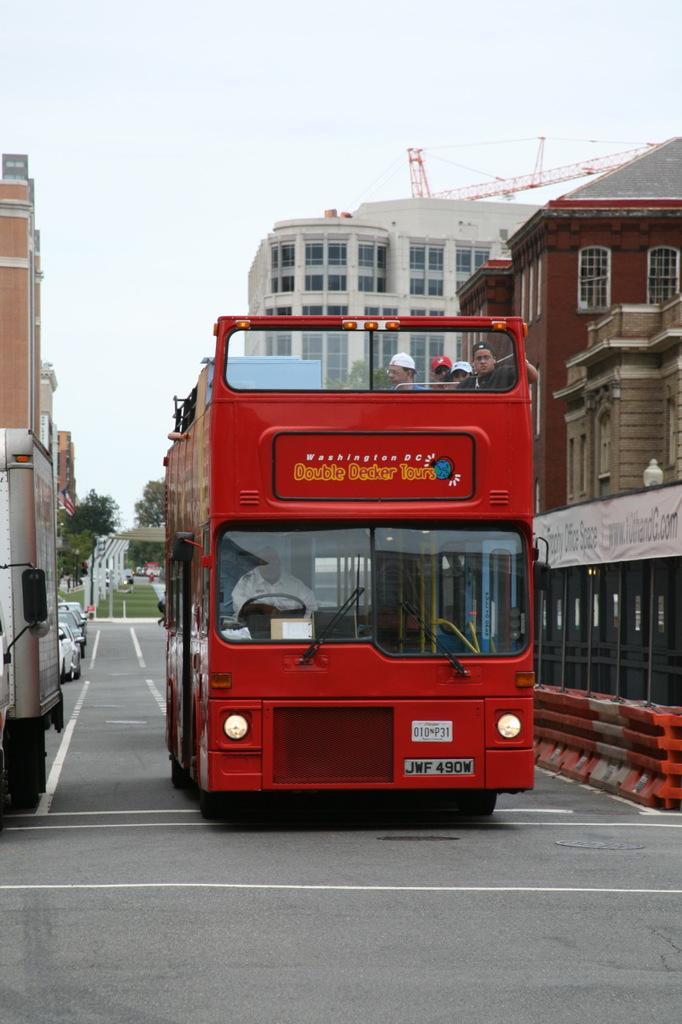Please provide a concise description of this image. In this picture we can see few vehicles on the road, and few people are seated in the bus, in the background we can see few trees, buildings and a crane. 